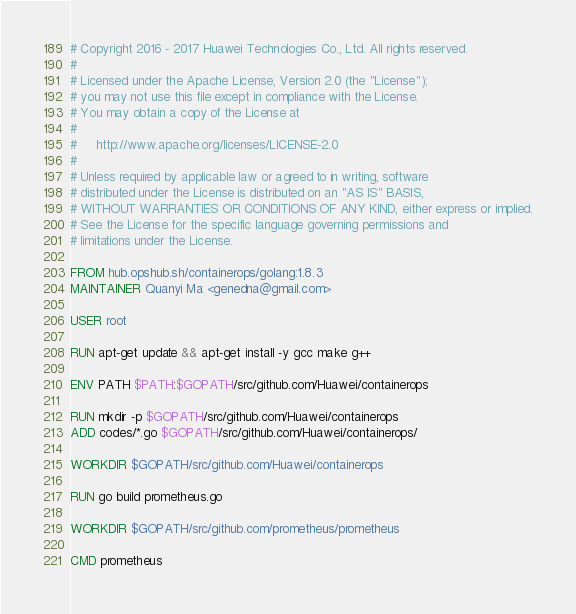Convert code to text. <code><loc_0><loc_0><loc_500><loc_500><_Dockerfile_># Copyright 2016 - 2017 Huawei Technologies Co., Ltd. All rights reserved.
#
# Licensed under the Apache License, Version 2.0 (the "License");
# you may not use this file except in compliance with the License.
# You may obtain a copy of the License at
#
#     http://www.apache.org/licenses/LICENSE-2.0
#
# Unless required by applicable law or agreed to in writing, software
# distributed under the License is distributed on an "AS IS" BASIS,
# WITHOUT WARRANTIES OR CONDITIONS OF ANY KIND, either express or implied.
# See the License for the specific language governing permissions and
# limitations under the License.

FROM hub.opshub.sh/containerops/golang:1.8.3
MAINTAINER Quanyi Ma <genedna@gmail.com>

USER root

RUN apt-get update && apt-get install -y gcc make g++ 

ENV PATH $PATH:$GOPATH/src/github.com/Huawei/containerops

RUN mkdir -p $GOPATH/src/github.com/Huawei/containerops
ADD codes/*.go $GOPATH/src/github.com/Huawei/containerops/

WORKDIR $GOPATH/src/github.com/Huawei/containerops

RUN go build prometheus.go

WORKDIR $GOPATH/src/github.com/prometheus/prometheus

CMD prometheus
</code> 